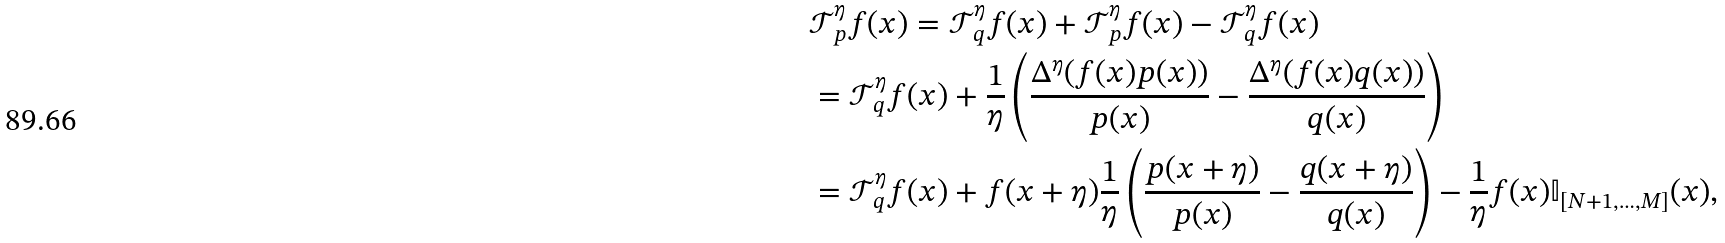Convert formula to latex. <formula><loc_0><loc_0><loc_500><loc_500>& \mathcal { T } _ { p } ^ { \eta } f ( x ) = \mathcal { T } _ { q } ^ { \eta } f ( x ) + \mathcal { T } _ { p } ^ { \eta } f ( x ) - \mathcal { T } _ { q } ^ { \eta } f ( x ) \\ & = \mathcal { T } _ { q } ^ { \eta } f ( x ) + \frac { 1 } { \eta } \left ( \frac { \Delta ^ { \eta } ( f ( x ) p ( x ) ) } { p ( x ) } - \frac { \Delta ^ { \eta } ( f ( x ) q ( x ) ) } { q ( x ) } \right ) \\ & = \mathcal { T } _ { q } ^ { \eta } f ( x ) + f ( x + \eta ) \frac { 1 } { \eta } \left ( \frac { p ( x + \eta ) } { p ( x ) } - \frac { q ( x + \eta ) } { q ( x ) } \right ) - \frac { 1 } { \eta } f ( x ) \mathbb { I } _ { [ N + 1 , \dots , M ] } ( x ) ,</formula> 